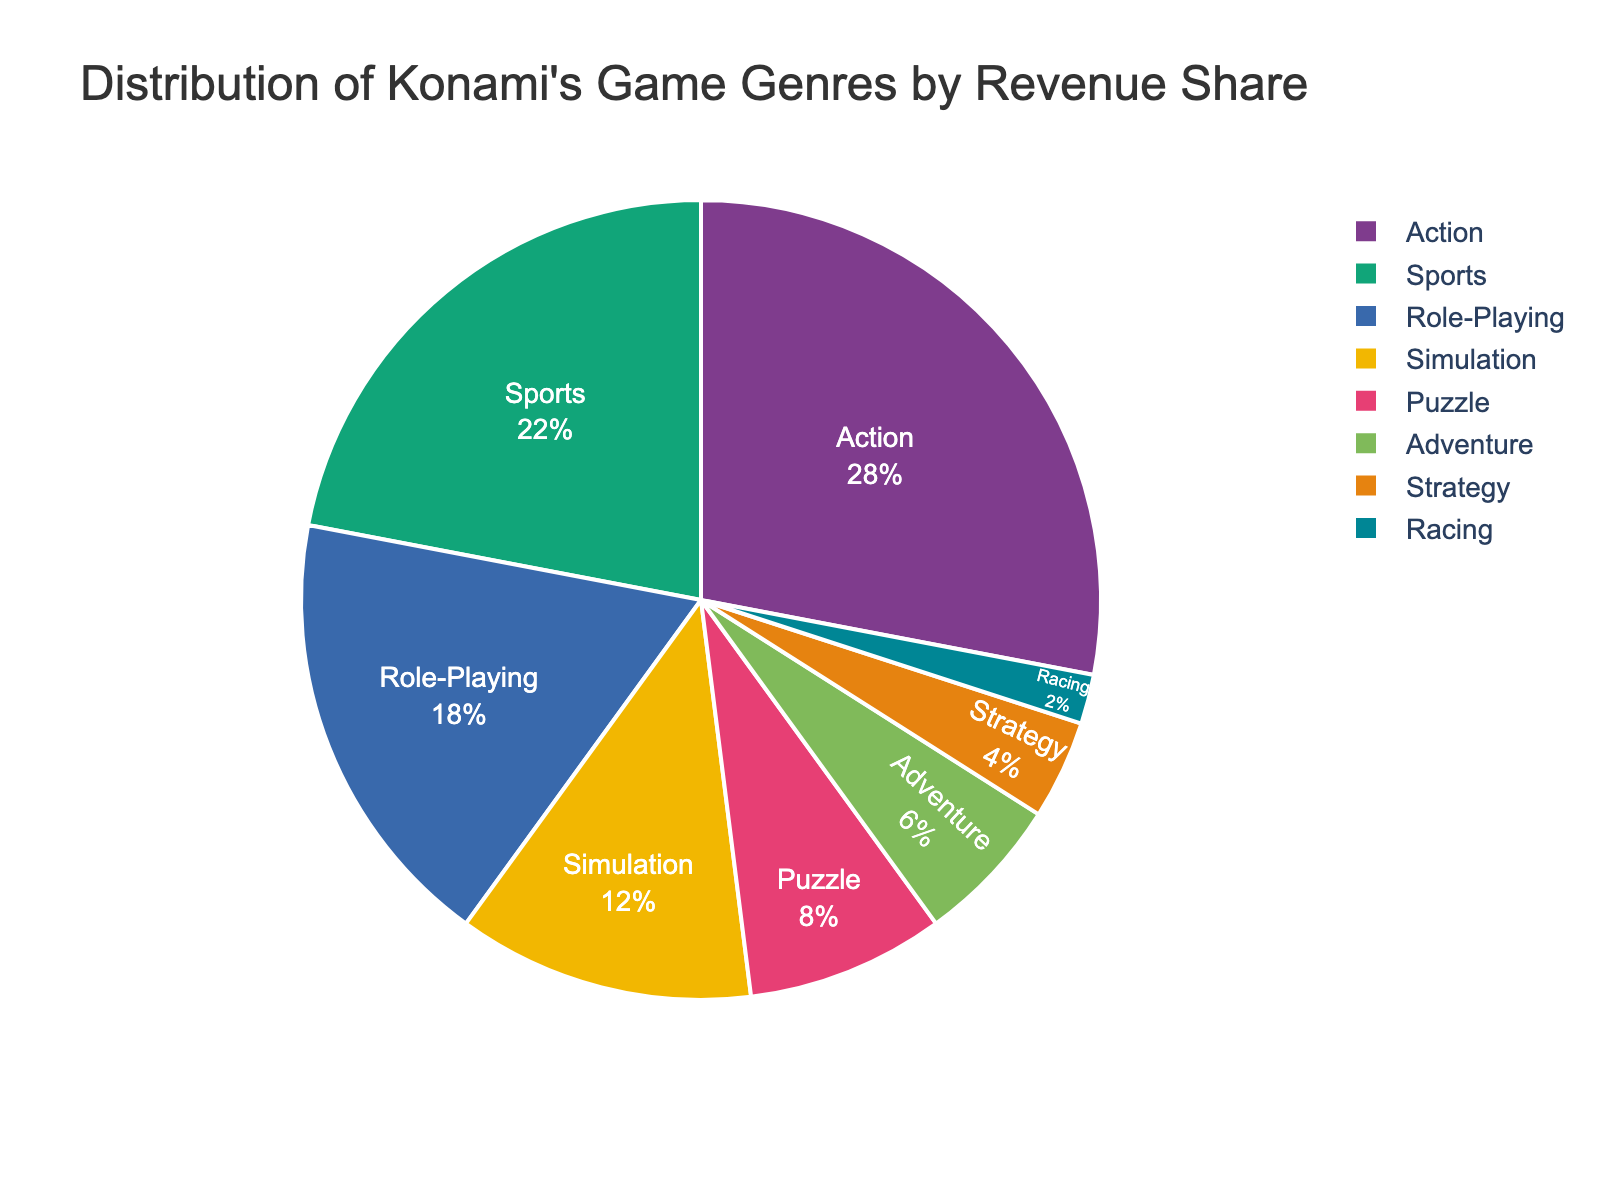What's the combined revenue share of the Puzzle and Racing genres? First, find the revenue share of the Puzzle genre, which is 8%, and the Racing genre, which is 2%. Then, sum these two values: 8% + 2% = 10%.
Answer: 10% Which genre has a higher revenue share, Role-Playing or Simulation? Compare the revenue shares of Role-Playing (18%) and Simulation (12%). Since 18% is greater than 12%, Role-Playing has the higher revenue share.
Answer: Role-Playing What is the difference in revenue share between the Action and Adventure genres? The revenue share for Action is 28% and for Adventure is 6%. Subtract the Adventure revenue share from the Action revenue share: 28% - 6% = 22%.
Answer: 22% Which genre has the smallest revenue share and what is its value? Identify the genre with the smallest piece in the pie chart, which represents the Racing genre. The revenue share for Racing is 2%.
Answer: Racing, 2% How much more revenue share does the Sports genre have compared to the Puzzle genre? The Sports genre has a revenue share of 22%, and the Puzzle genre has 8%. Subtract the Puzzle share from the Sports share: 22% - 8% = 14%.
Answer: 14% Which genre occupies the largest segment of the pie chart, and what is its revenue share? Find the largest segment in the pie chart, which belongs to the Action genre. The revenue share for this genre is 28%.
Answer: Action, 28% By how much does the combined share of Sports and Simulation surpass Role-Playing? Calculate the combined share of Sports (22%) and Simulation (12%), which is 34%. The Role-Playing share is 18%. Subtract the Role-Playing share from the combined share: 34% - 18% = 16%.
Answer: 16% What proportion of the total revenue share is contributed by Strategy, Racing, and Adventure genres combined? Add the revenue shares of the Strategy (4%), Racing (2%), and Adventure (6%) genres: 4% + 2% + 6% = 12%.
Answer: 12% Among the genres that exceed a 10% revenue share, how many are there? Identify and count the genres with revenue shares above 10%: Action (28%), Sports (22%), Role-Playing (18%), and Simulation (12%). There are 4 such genres.
Answer: 4 